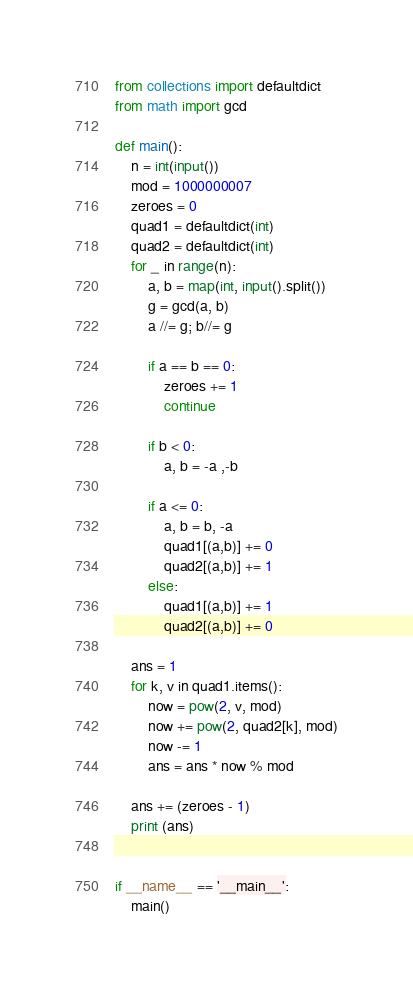<code> <loc_0><loc_0><loc_500><loc_500><_Python_>from collections import defaultdict
from math import gcd

def main():
    n = int(input())
    mod = 1000000007
    zeroes = 0
    quad1 = defaultdict(int)
    quad2 = defaultdict(int)
    for _ in range(n):
        a, b = map(int, input().split())
        g = gcd(a, b)
        a //= g; b//= g

        if a == b == 0:
            zeroes += 1
            continue
        
        if b < 0:
            a, b = -a ,-b
        
        if a <= 0:
            a, b = b, -a
            quad1[(a,b)] += 0
            quad2[(a,b)] += 1
        else:
            quad1[(a,b)] += 1
            quad2[(a,b)] += 0

    ans = 1
    for k, v in quad1.items():
        now = pow(2, v, mod)
        now += pow(2, quad2[k], mod)
        now -= 1
        ans = ans * now % mod
    
    ans += (zeroes - 1)
    print (ans)


if __name__ == '__main__':
    main()</code> 